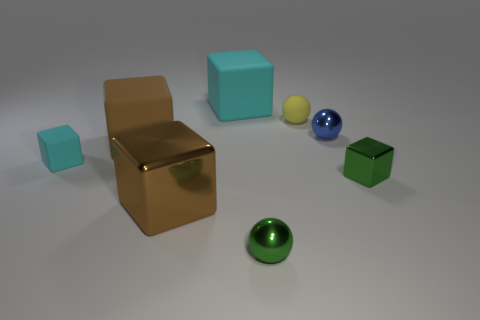What is the color of the tiny block on the right side of the tiny thing that is behind the sphere right of the yellow matte object?
Your answer should be very brief. Green. Is there a big brown metallic thing of the same shape as the yellow matte object?
Make the answer very short. No. Are there more blue metallic things in front of the large brown metallic block than blue spheres?
Give a very brief answer. No. How many metallic objects are tiny blue spheres or brown blocks?
Give a very brief answer. 2. What size is the rubber object that is behind the blue ball and in front of the large cyan rubber cube?
Your answer should be compact. Small. There is a small block left of the tiny rubber sphere; are there any cyan things to the right of it?
Offer a very short reply. Yes. There is a large metallic block; what number of brown matte things are to the right of it?
Offer a very short reply. 0. There is another shiny object that is the same shape as the tiny blue object; what color is it?
Keep it short and to the point. Green. Is the material of the brown cube that is in front of the tiny cyan matte block the same as the cyan object behind the small cyan rubber cube?
Provide a short and direct response. No. Is the color of the small rubber cube the same as the small metallic sphere in front of the brown rubber block?
Your answer should be very brief. No. 